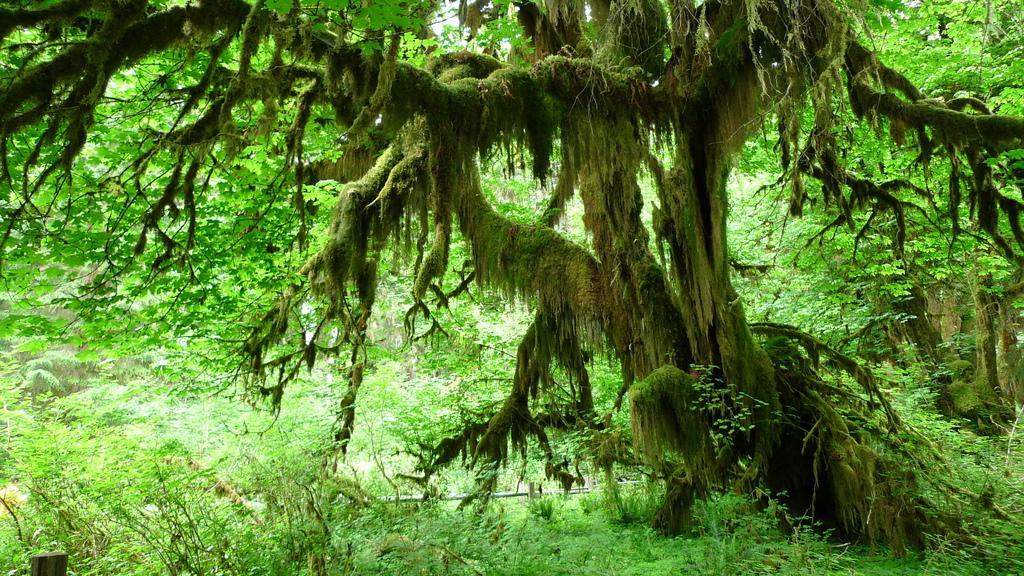Please provide a concise description of this image. In this image I can see few trees in green color. 